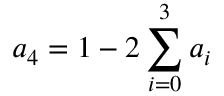Convert formula to latex. <formula><loc_0><loc_0><loc_500><loc_500>a _ { 4 } = 1 - 2 \sum _ { i = 0 } ^ { 3 } a _ { i }</formula> 